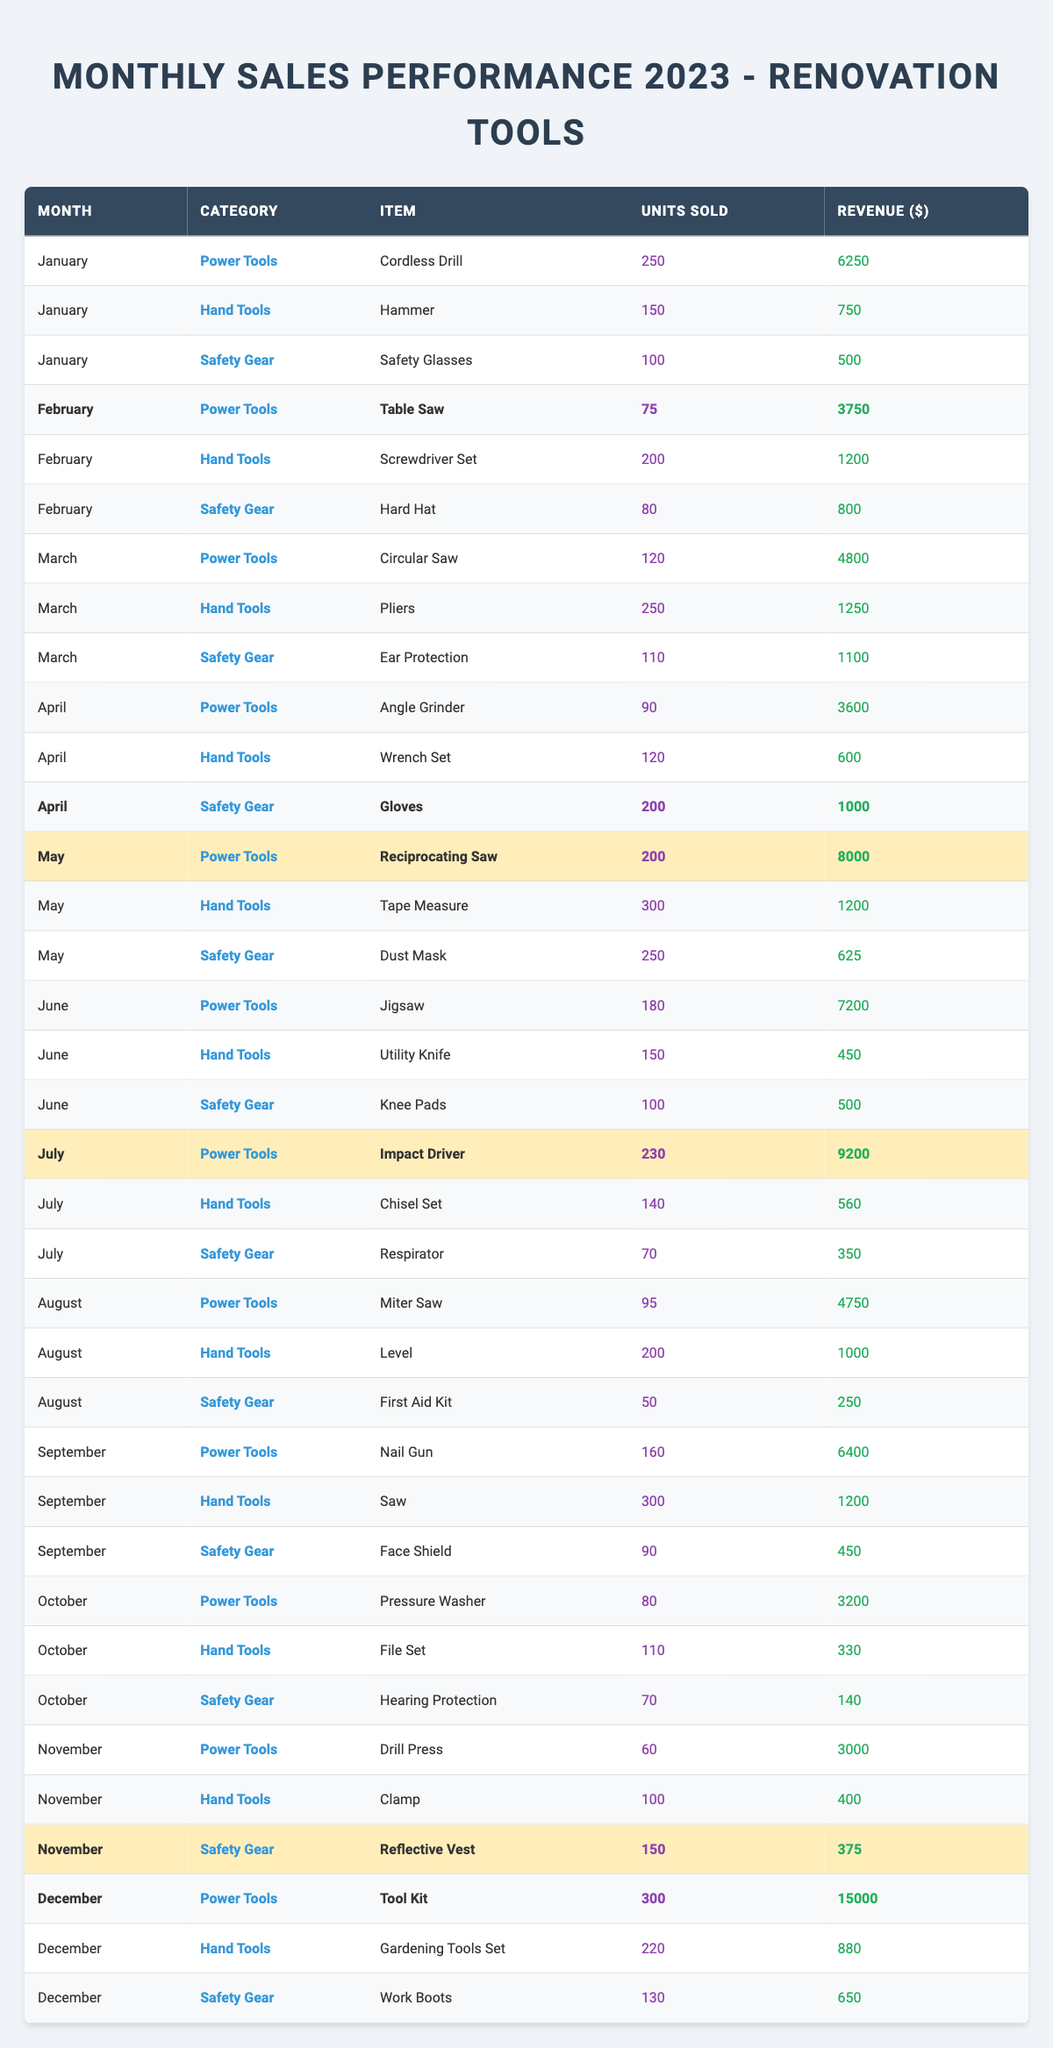What item sold the most units in December? In December, the item with the highest units sold is the "Tool Kit," with 300 units sold as noted in the table.
Answer: Tool Kit Which month had the highest revenue from Power Tools? The highest revenue from Power Tools occurred in December with the "Tool Kit," generating $15,000 in revenue.
Answer: December Were any Safety Gear items highlighted in the table? Yes, the "Gloves" in April, "Reflective Vest" in November, and "Work Boots" in December are highlighted, indicating significant sales performance.
Answer: Yes How many units of Hand Tools were sold in May? The table indicates that 300 units of the "Tape Measure," which is a Hand Tool, were sold in May.
Answer: 300 What is the total revenue generated by Safety Gear in April and May combined? In April, the "Gloves" generated $1,000, while in May, the "Dust Mask" generated $625. Summing these gives $1,000 + $625 = $1,625.
Answer: 1625 Which month had the least number of units sold overall? By reviewing the table headings, November has the fewest total units sold, with 60 for the "Drill Press."
Answer: November Which category overall achieved the highest revenue in July? The "Power Tools" category had the highest revenue in July, particularly the "Impact Driver," generating $9,200 in revenue, compared to other categories.
Answer: Power Tools How many Power Tools were sold in the first half of the year compared to the second half? In the first half (January to June), total Power Tools units are 250+75+120+90+200+180 = 1,015. In the second half (July to December), total units are 230 + 95 + 160 + 80 + 60 + 300 = 925. Thus, the first half had higher sales.
Answer: First half What percentage of the total units sold for Safety Gear in the year were in December? The total units sold for Safety Gear in 2023 is (100 + 80 + 110 + 200 + 250 + 100 + 70 + 90 + 70 + 150 + 130) = 1,050. In December, 130 units were sold. Therefore, the percentage is (130 / 1,050) * 100 ≈ 12.38%.
Answer: 12.38% What was the average revenue of Hand Tools sold in the month of January? For Hand Tools in January, revenue from "Hammer" is $750. Thus, there is only one item in January for Hand Tools, making the average the same as the total, which is $750.
Answer: 750 How much more revenue did the "Tool Kit" earn compared to the other Power Tools in December? The "Tool Kit" generated $15,000. The next highest Power Tool revenue in December was the "Pressure Washer" at $3,200. The difference is $15,000 - $3,200 = $11,800.
Answer: 11800 